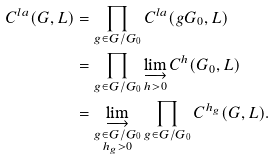<formula> <loc_0><loc_0><loc_500><loc_500>C ^ { l a } ( G , L ) & = \prod _ { g \in G / G _ { 0 } } C ^ { l a } ( g G _ { 0 } , L ) \\ & = \prod _ { g \in G / G _ { 0 } } \varinjlim _ { h > 0 } C ^ { h } ( G _ { 0 } , L ) \\ & = \varinjlim _ { \substack { g \in G / G _ { 0 } \\ h _ { g } > 0 } } \prod _ { g \in G / G _ { 0 } } C ^ { h _ { g } } ( G , L ) .</formula> 